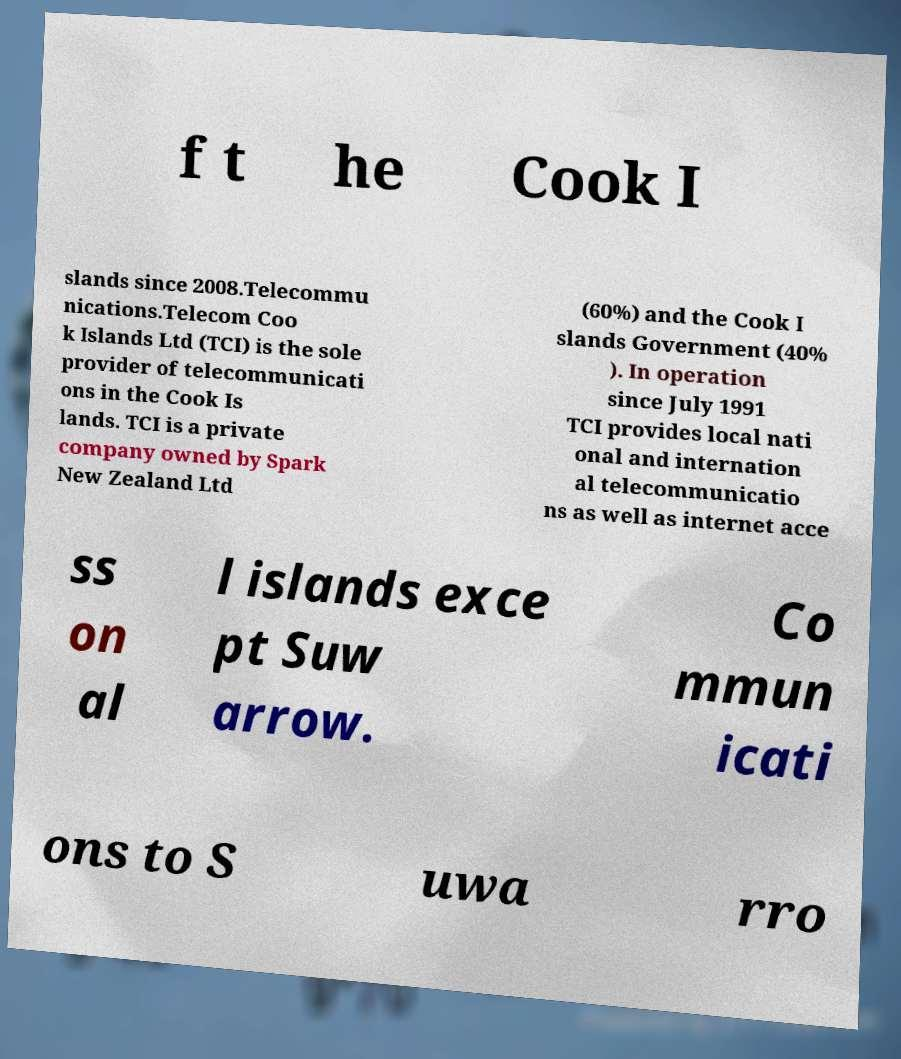There's text embedded in this image that I need extracted. Can you transcribe it verbatim? f t he Cook I slands since 2008.Telecommu nications.Telecom Coo k Islands Ltd (TCI) is the sole provider of telecommunicati ons in the Cook Is lands. TCI is a private company owned by Spark New Zealand Ltd (60%) and the Cook I slands Government (40% ). In operation since July 1991 TCI provides local nati onal and internation al telecommunicatio ns as well as internet acce ss on al l islands exce pt Suw arrow. Co mmun icati ons to S uwa rro 